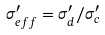Convert formula to latex. <formula><loc_0><loc_0><loc_500><loc_500>\sigma ^ { \prime } _ { e f f } = \sigma ^ { \prime } _ { d } / \sigma ^ { \prime } _ { c }</formula> 